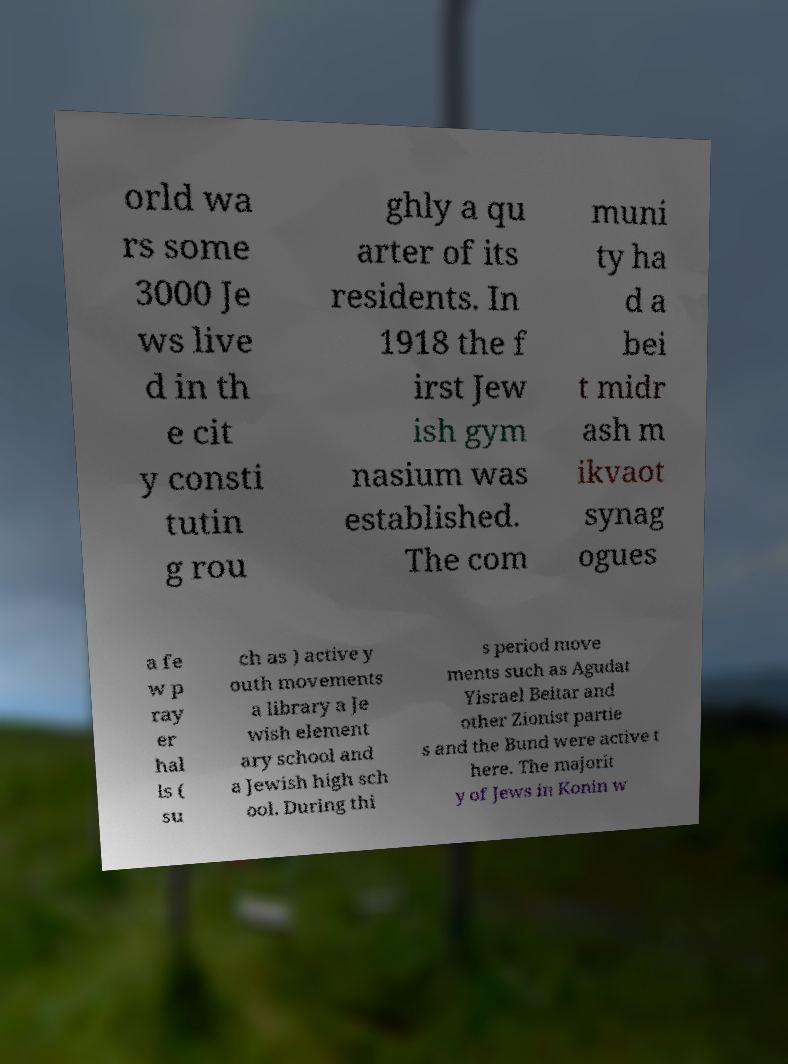Can you accurately transcribe the text from the provided image for me? orld wa rs some 3000 Je ws live d in th e cit y consti tutin g rou ghly a qu arter of its residents. In 1918 the f irst Jew ish gym nasium was established. The com muni ty ha d a bei t midr ash m ikvaot synag ogues a fe w p ray er hal ls ( su ch as ) active y outh movements a library a Je wish element ary school and a Jewish high sch ool. During thi s period move ments such as Agudat Yisrael Beitar and other Zionist partie s and the Bund were active t here. The majorit y of Jews in Konin w 